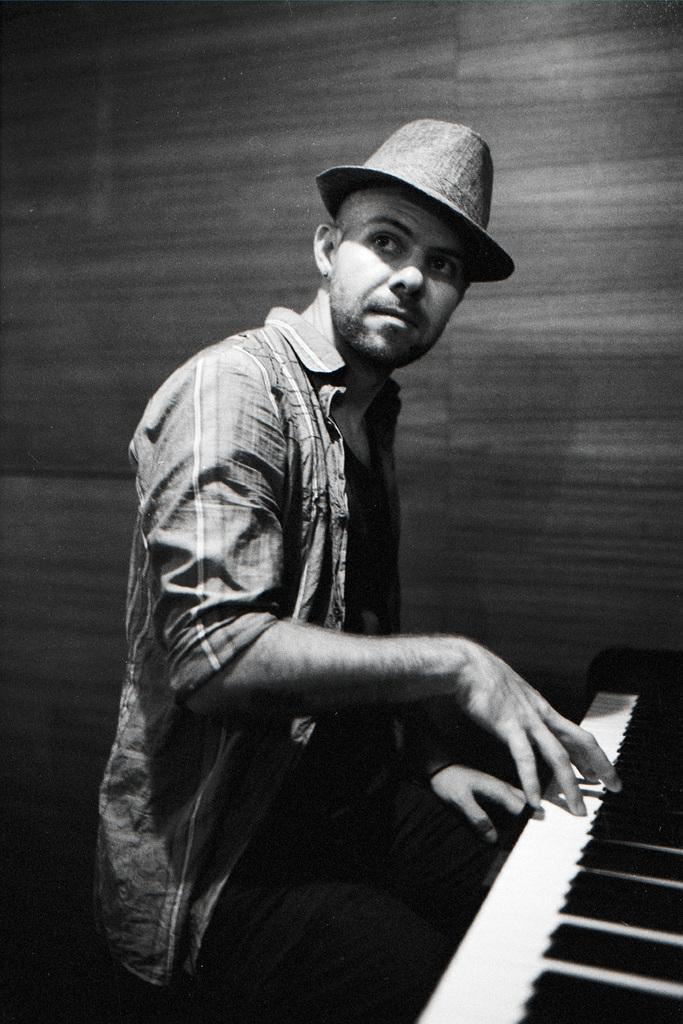How would you summarize this image in a sentence or two? In this image I see a man who is wearing a cap and he kept his hands on the piano. 